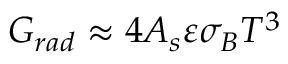<formula> <loc_0><loc_0><loc_500><loc_500>G _ { r a d } \approx 4 A _ { s } \varepsilon \sigma _ { B } T ^ { 3 }</formula> 